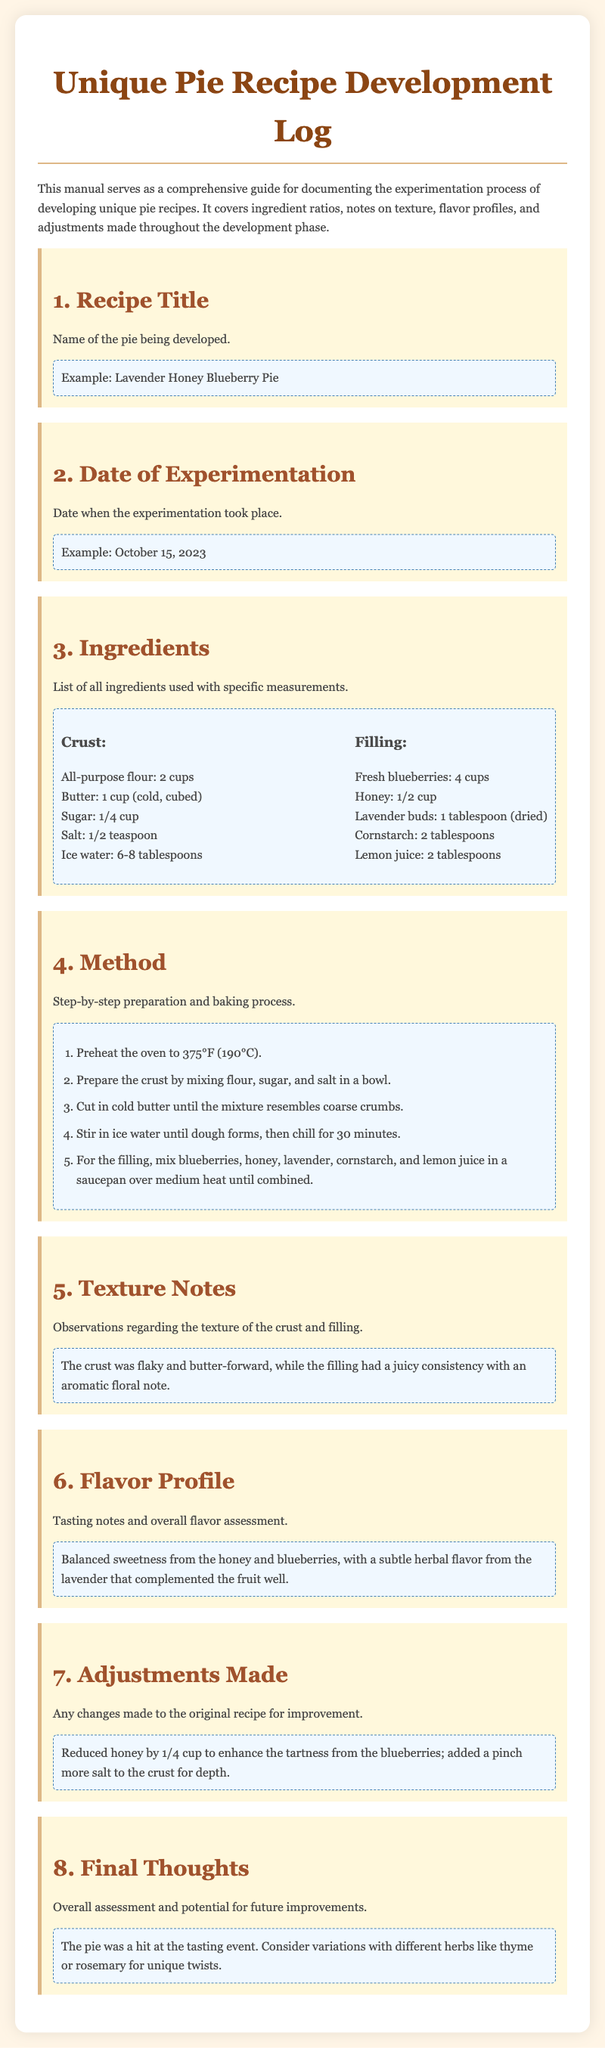what is the name of the pie being developed? The name of the pie is indicated in the recipe title section of the document.
Answer: Lavender Honey Blueberry Pie what is the date of experimentation? The date is specified in the date of experimentation section.
Answer: October 15, 2023 how many cups of all-purpose flour are used in the crust? The amount is listed in the ingredients section under crust.
Answer: 2 cups what adjustment was made to enhance the tartness? The adjustment is discussed in the adjustments made section regarding the original recipe.
Answer: Reduced honey by 1/4 cup what texture note is given for the crust? Texture notes are provided in the texture notes section of the document.
Answer: Flaky and butter-forward describe the overall flavor assessment The flavor profile section includes a detailed description of the flavor.
Answer: Balanced sweetness from the honey and blueberries how many tablespoons of cornstarch are used in the filling? The measurement is mentioned under the filling ingredients.
Answer: 2 tablespoons what is the method of preparation for the crust? The method section provides step-by-step instructions for crust preparation.
Answer: Mixing flour, sugar, and salt in a bowl what is a potential variation suggested for future recipes? Final thoughts include recommendations for variations in future experiments.
Answer: Different herbs like thyme or rosemary 